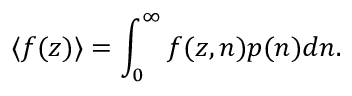<formula> <loc_0><loc_0><loc_500><loc_500>\langle f ( z ) \rangle = \int _ { 0 } ^ { \infty } f ( z , n ) p ( n ) d n .</formula> 